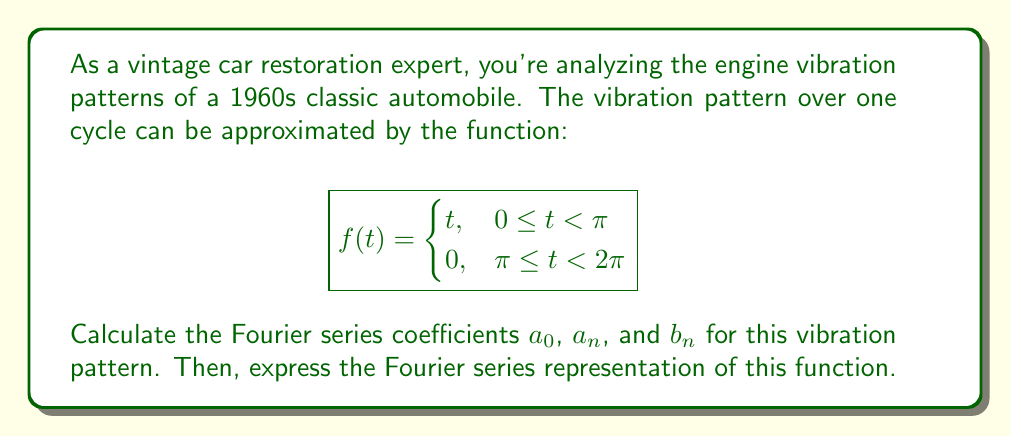Can you answer this question? Let's approach this step-by-step:

1) First, we need to calculate $a_0$, which represents the average value of the function over one period:

   $$a_0 = \frac{1}{2\pi} \int_0^{2\pi} f(t) dt = \frac{1}{2\pi} \left(\int_0^{\pi} t dt + \int_{\pi}^{2\pi} 0 dt\right) = \frac{1}{2\pi} \cdot \frac{\pi^2}{2} = \frac{\pi}{4}$$

2) Next, we calculate $a_n$:

   $$a_n = \frac{1}{\pi} \int_0^{2\pi} f(t) \cos(nt) dt = \frac{1}{\pi} \int_0^{\pi} t \cos(nt) dt$$

   Integrating by parts:
   
   $$a_n = \frac{1}{\pi} \left[\frac{t \sin(nt)}{n}\right]_0^{\pi} - \frac{1}{\pi n} \int_0^{\pi} \sin(nt) dt$$
   
   $$= \frac{1}{\pi} \cdot \frac{\pi \sin(n\pi)}{n} - \frac{1}{\pi n} \left[-\frac{\cos(nt)}{n}\right]_0^{\pi}$$
   
   $$= 0 + \frac{1}{\pi n^2} [\cos(n\pi) - 1] = \frac{(-1)^n - 1}{\pi n^2}$$

3) Finally, we calculate $b_n$:

   $$b_n = \frac{1}{\pi} \int_0^{2\pi} f(t) \sin(nt) dt = \frac{1}{\pi} \int_0^{\pi} t \sin(nt) dt$$

   Integrating by parts:
   
   $$b_n = \frac{1}{\pi} \left[-\frac{t \cos(nt)}{n}\right]_0^{\pi} + \frac{1}{\pi n} \int_0^{\pi} \cos(nt) dt$$
   
   $$= -\frac{1}{\pi} \cdot \frac{\pi \cos(n\pi)}{n} + \frac{1}{\pi n} \left[\frac{\sin(nt)}{n}\right]_0^{\pi}$$
   
   $$= \frac{(-1)^{n+1}}{n} + 0 = \frac{(-1)^{n+1}}{n}$$

4) The Fourier series representation is given by:

   $$f(t) = \frac{a_0}{2} + \sum_{n=1}^{\infty} (a_n \cos(nt) + b_n \sin(nt))$$

Substituting our calculated values:

$$f(t) = \frac{\pi}{8} + \sum_{n=1}^{\infty} \left(\frac{(-1)^n - 1}{\pi n^2} \cos(nt) + \frac{(-1)^{n+1}}{n} \sin(nt)\right)$$

This is the Fourier series representation of the engine vibration pattern.
Answer: $$f(t) = \frac{\pi}{8} + \sum_{n=1}^{\infty} \left(\frac{(-1)^n - 1}{\pi n^2} \cos(nt) + \frac{(-1)^{n+1}}{n} \sin(nt)\right)$$
Where:
$a_0 = \frac{\pi}{4}$
$a_n = \frac{(-1)^n - 1}{\pi n^2}$
$b_n = \frac{(-1)^{n+1}}{n}$ 